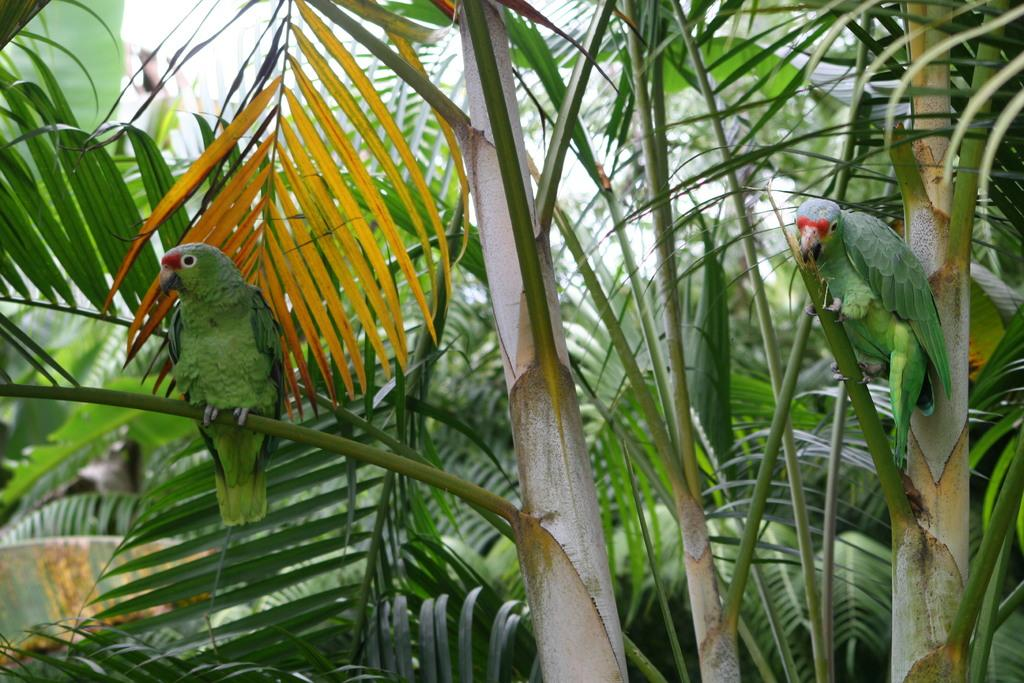What is present in the image? There is a tree in the image. Are there any animals on the tree? Yes, there are two parrots on the tree. Where is the sofa located in the image? There is no sofa present in the image. What time does the clock show in the image? There is no clock present in the image. 